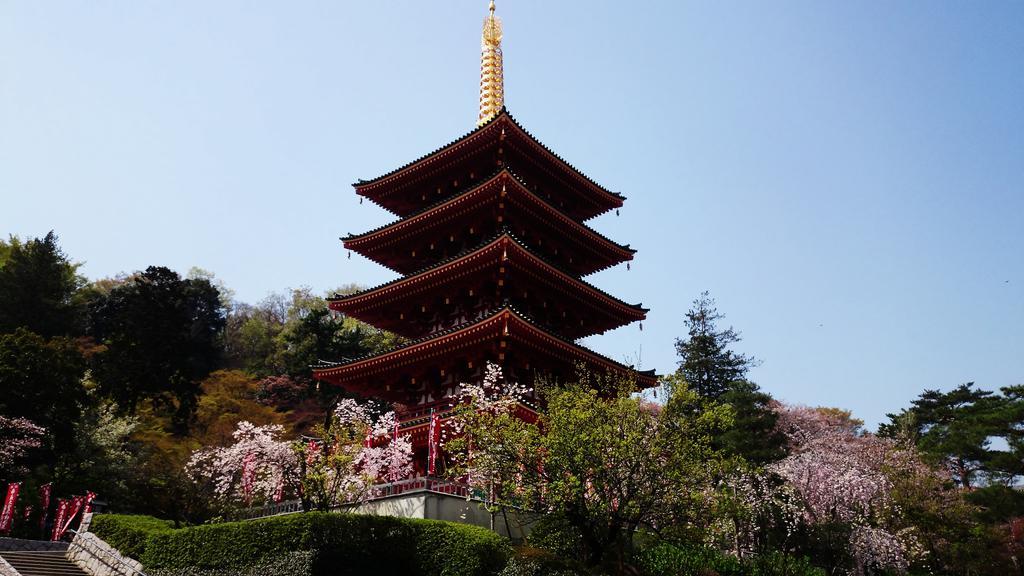How would you summarize this image in a sentence or two? In the foreground of the picture there are trees, plants and staircase. In the center of the picture there is a table. On the left there are trees. On the right there are trees. In the background it is sky. 